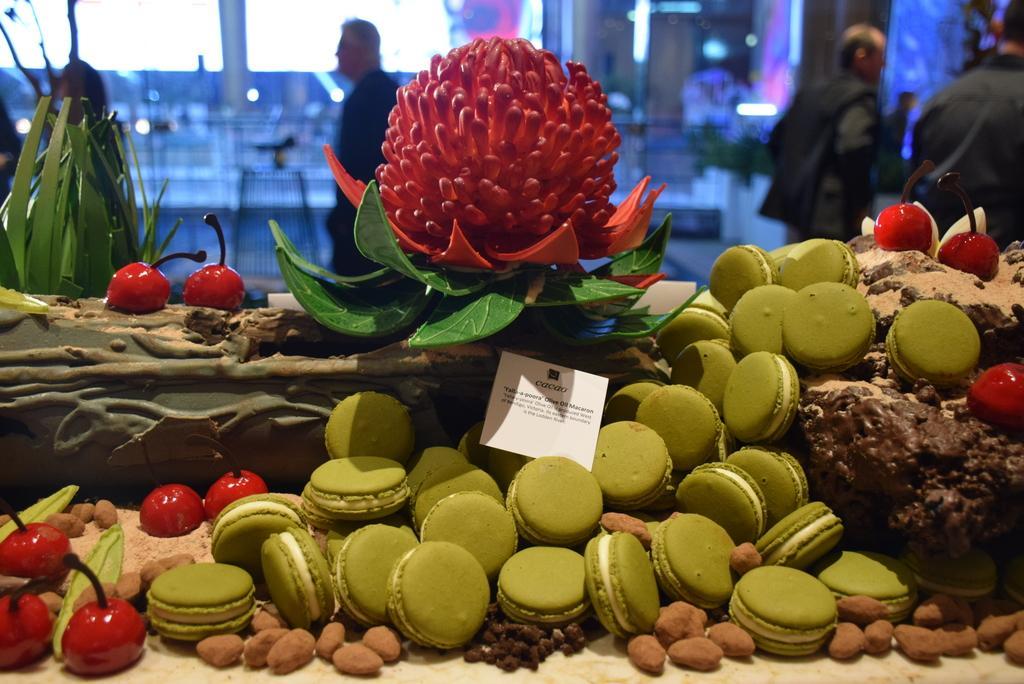Describe this image in one or two sentences. In the foreground of this picture we can see the biscuits and many other food items. The background of the image is blurry and we can see the group of persons and some other objects. 